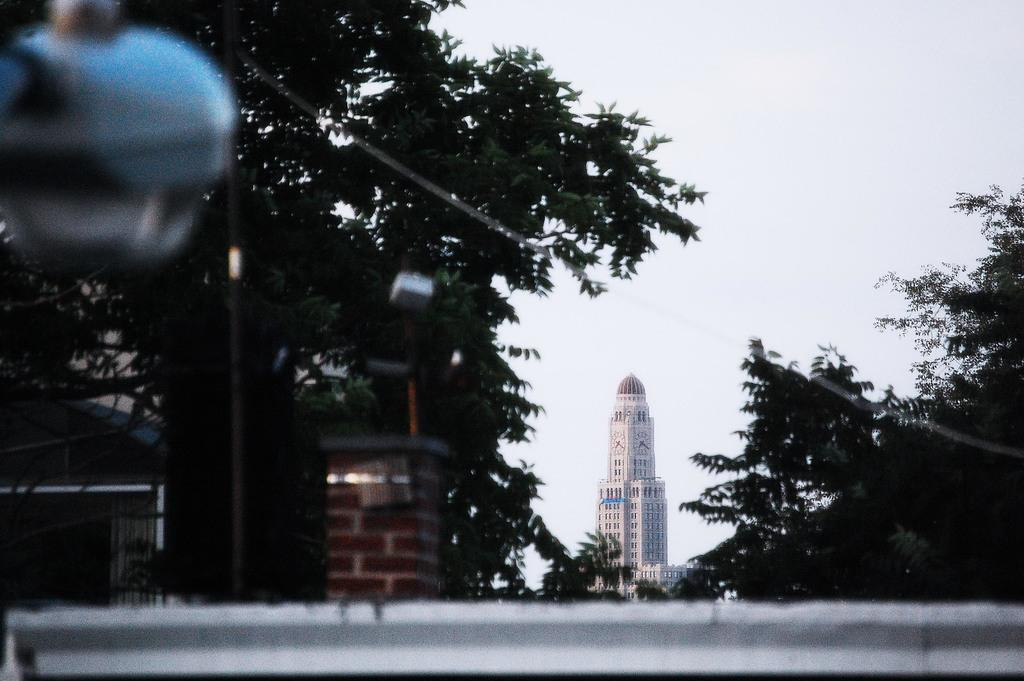What is the main structure in the center of the image? There is a building in the center of the image. What type of support structure can be seen in the image? There is a truss and a pillar in the image. What type of lighting is present in the image? There is a pole light in the image. What is visible at the top of the image? The sky is visible at the top of the image. What type of barrier is present at the bottom of the image? There is a wall at the bottom of the image. What is the account of the building's construction in the image? There is no information about the building's construction in the image. What is the opinion of the truss on the building's stability? There is no opinion expressed about the truss's stability in the image. 